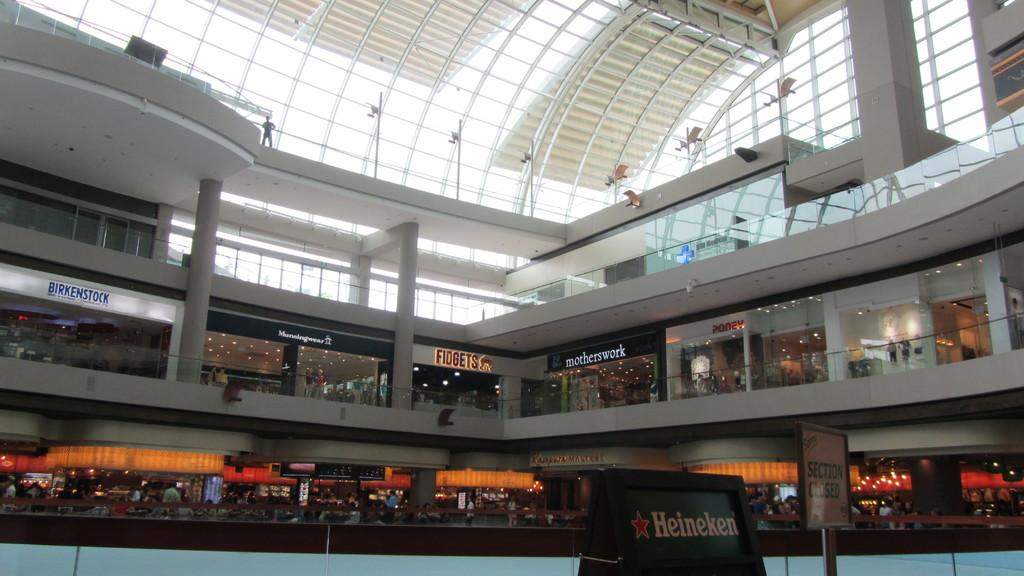What type of location is depicted in the image? The image shows an interior view of a building. What can be found within this building? There are multiple shops visible in the image. Are there any architectural features present in the image? Yes, there are pillars in the image. Are there any people present in the image? Yes, there are people present in the image. Can any text or writing be seen in the image? Yes, there is writing visible at some places in the image. What type of circle can be seen on the floor in the image? There is no circle visible on the floor in the image. Is there a beggar present in the image? There is no beggar present in the image. 